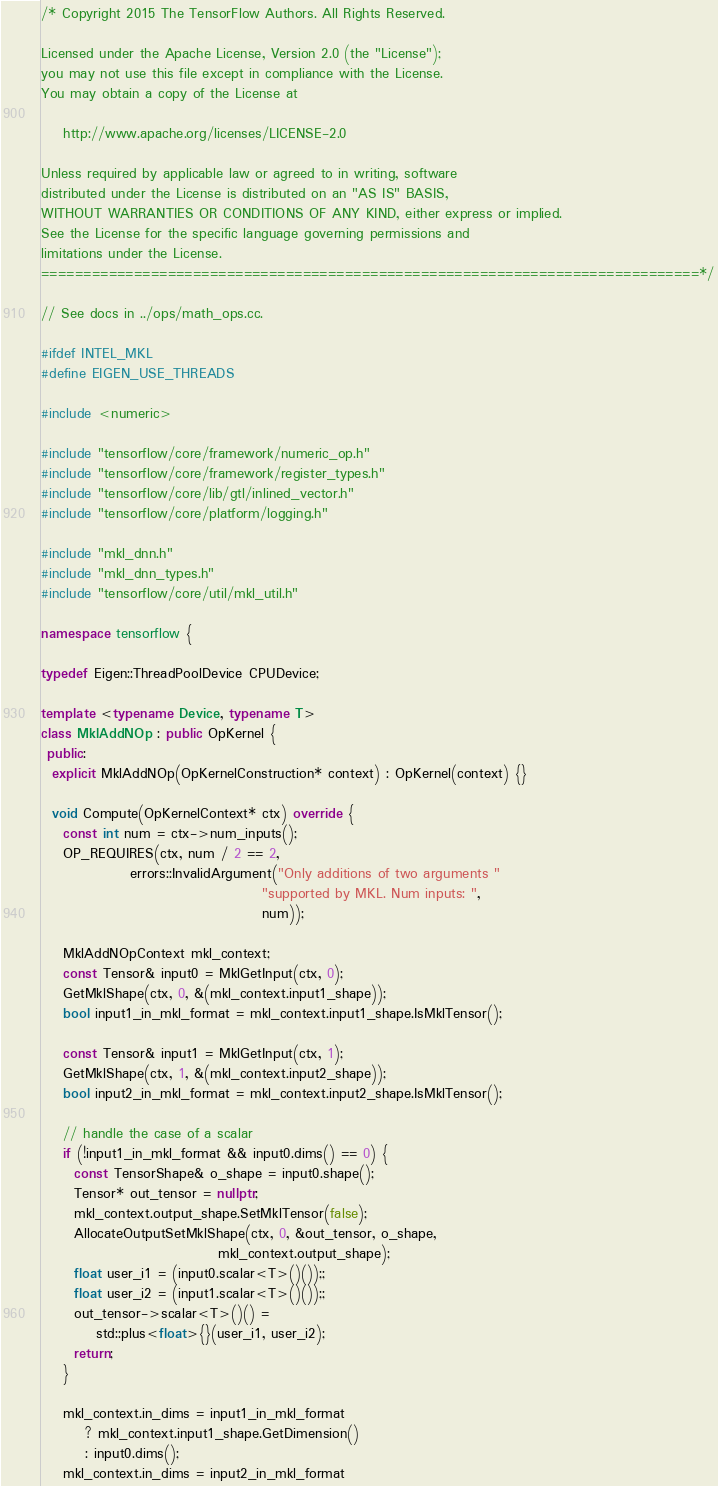Convert code to text. <code><loc_0><loc_0><loc_500><loc_500><_C++_>/* Copyright 2015 The TensorFlow Authors. All Rights Reserved.

Licensed under the Apache License, Version 2.0 (the "License");
you may not use this file except in compliance with the License.
You may obtain a copy of the License at

    http://www.apache.org/licenses/LICENSE-2.0

Unless required by applicable law or agreed to in writing, software
distributed under the License is distributed on an "AS IS" BASIS,
WITHOUT WARRANTIES OR CONDITIONS OF ANY KIND, either express or implied.
See the License for the specific language governing permissions and
limitations under the License.
==============================================================================*/

// See docs in ../ops/math_ops.cc.

#ifdef INTEL_MKL
#define EIGEN_USE_THREADS

#include <numeric>

#include "tensorflow/core/framework/numeric_op.h"
#include "tensorflow/core/framework/register_types.h"
#include "tensorflow/core/lib/gtl/inlined_vector.h"
#include "tensorflow/core/platform/logging.h"

#include "mkl_dnn.h"
#include "mkl_dnn_types.h"
#include "tensorflow/core/util/mkl_util.h"

namespace tensorflow {

typedef Eigen::ThreadPoolDevice CPUDevice;

template <typename Device, typename T>
class MklAddNOp : public OpKernel {
 public:
  explicit MklAddNOp(OpKernelConstruction* context) : OpKernel(context) {}

  void Compute(OpKernelContext* ctx) override {
    const int num = ctx->num_inputs();
    OP_REQUIRES(ctx, num / 2 == 2,
                errors::InvalidArgument("Only additions of two arguments "
                                        "supported by MKL. Num inputs: ",
                                        num));

    MklAddNOpContext mkl_context;
    const Tensor& input0 = MklGetInput(ctx, 0);
    GetMklShape(ctx, 0, &(mkl_context.input1_shape));
    bool input1_in_mkl_format = mkl_context.input1_shape.IsMklTensor();

    const Tensor& input1 = MklGetInput(ctx, 1);
    GetMklShape(ctx, 1, &(mkl_context.input2_shape));
    bool input2_in_mkl_format = mkl_context.input2_shape.IsMklTensor();

    // handle the case of a scalar
    if (!input1_in_mkl_format && input0.dims() == 0) {
      const TensorShape& o_shape = input0.shape();
      Tensor* out_tensor = nullptr;
      mkl_context.output_shape.SetMklTensor(false);
      AllocateOutputSetMklShape(ctx, 0, &out_tensor, o_shape,
                                mkl_context.output_shape);
      float user_i1 = (input0.scalar<T>()());;
      float user_i2 = (input1.scalar<T>()());;
      out_tensor->scalar<T>()() =
          std::plus<float>{}(user_i1, user_i2);
      return;
    }

    mkl_context.in_dims = input1_in_mkl_format
        ? mkl_context.input1_shape.GetDimension()
        : input0.dims();
    mkl_context.in_dims = input2_in_mkl_format</code> 